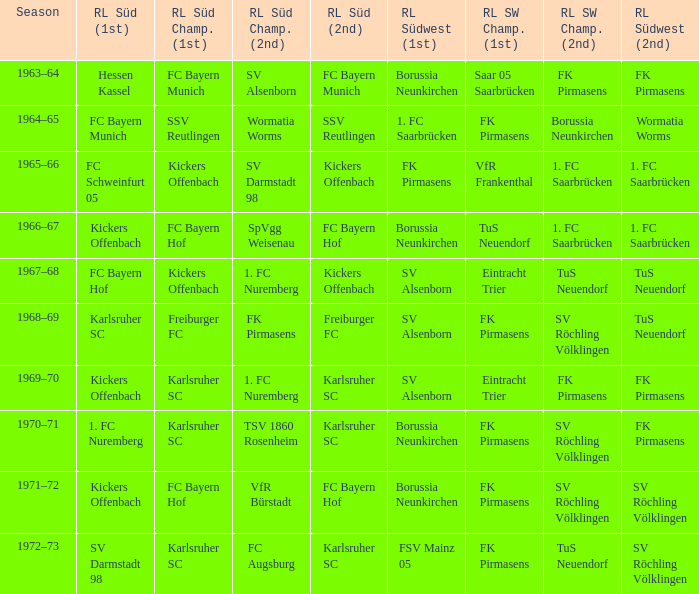What season did SV Darmstadt 98 end up at RL Süd (1st)? 1972–73. 